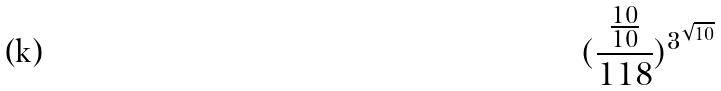<formula> <loc_0><loc_0><loc_500><loc_500>( \frac { \frac { 1 0 } { 1 0 } } { 1 1 8 } ) ^ { 3 ^ { \sqrt { 1 0 } } }</formula> 